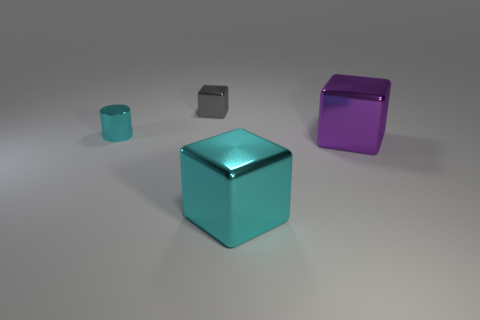Is the number of gray metallic things less than the number of yellow rubber cubes?
Your answer should be compact. No. The cyan thing to the right of the tiny object left of the thing that is behind the small cyan metallic thing is what shape?
Your answer should be very brief. Cube. What number of objects are either metallic objects in front of the tiny metallic cylinder or tiny shiny things that are right of the small cylinder?
Make the answer very short. 3. Are there any tiny metal blocks behind the tiny cyan cylinder?
Your answer should be compact. Yes. What number of objects are cyan objects in front of the purple object or rubber cylinders?
Offer a terse response. 1. What number of cyan things are either metallic objects or small metal things?
Offer a very short reply. 2. How many other things are there of the same color as the metal cylinder?
Provide a succinct answer. 1. Are there fewer big shiny things that are right of the small gray cube than big brown metallic spheres?
Your answer should be very brief. No. What color is the small thing that is right of the tiny object that is in front of the small metallic object that is behind the shiny cylinder?
Provide a short and direct response. Gray. The purple metal thing that is the same shape as the tiny gray shiny thing is what size?
Your response must be concise. Large. 